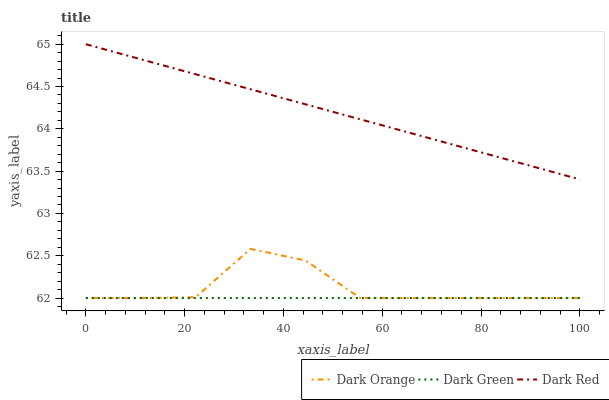Does Dark Green have the minimum area under the curve?
Answer yes or no. Yes. Does Dark Red have the maximum area under the curve?
Answer yes or no. Yes. Does Dark Red have the minimum area under the curve?
Answer yes or no. No. Does Dark Green have the maximum area under the curve?
Answer yes or no. No. Is Dark Green the smoothest?
Answer yes or no. Yes. Is Dark Orange the roughest?
Answer yes or no. Yes. Is Dark Red the smoothest?
Answer yes or no. No. Is Dark Red the roughest?
Answer yes or no. No. Does Dark Orange have the lowest value?
Answer yes or no. Yes. Does Dark Red have the lowest value?
Answer yes or no. No. Does Dark Red have the highest value?
Answer yes or no. Yes. Does Dark Green have the highest value?
Answer yes or no. No. Is Dark Orange less than Dark Red?
Answer yes or no. Yes. Is Dark Red greater than Dark Orange?
Answer yes or no. Yes. Does Dark Orange intersect Dark Green?
Answer yes or no. Yes. Is Dark Orange less than Dark Green?
Answer yes or no. No. Is Dark Orange greater than Dark Green?
Answer yes or no. No. Does Dark Orange intersect Dark Red?
Answer yes or no. No. 